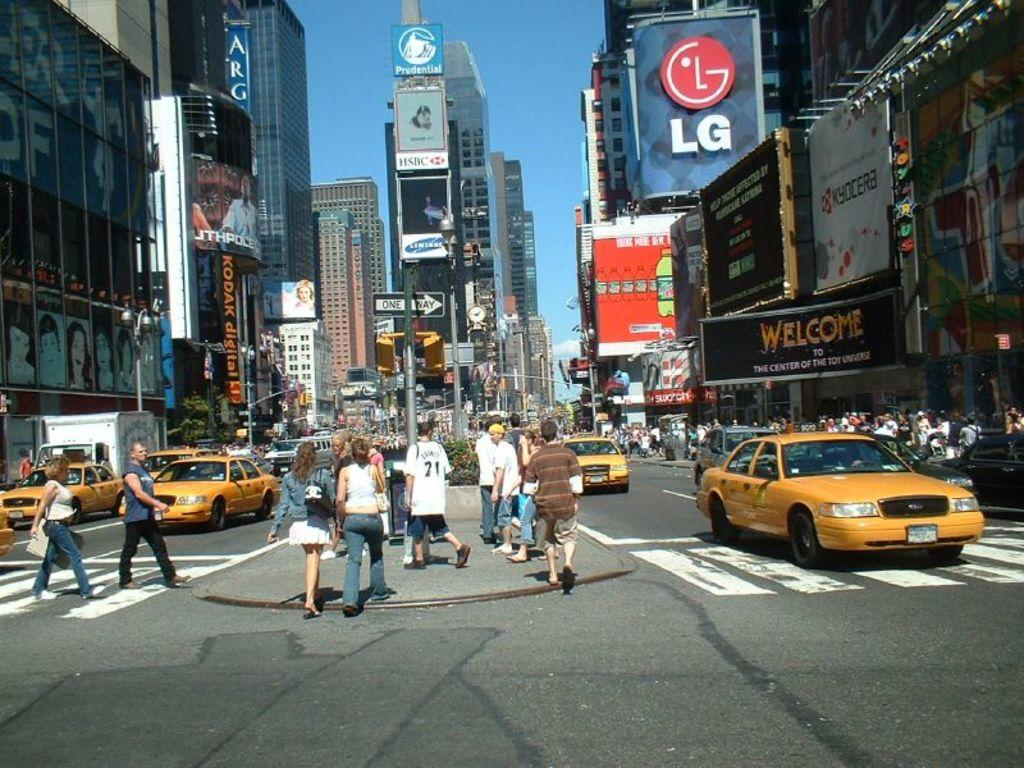<image>
Share a concise interpretation of the image provided. Many people and yellow cabs are seen on a street with large buildings and lots of advertising including LG, Kycoera, Kodak Digital, and Mountain Dew. 